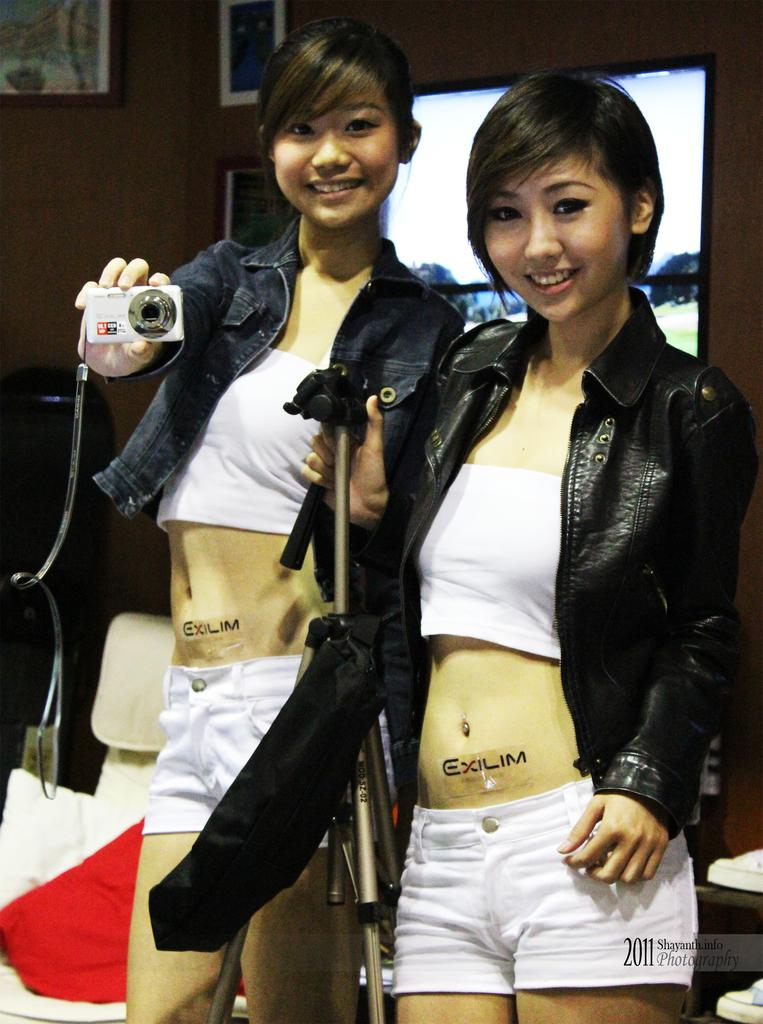How many women are in the image? There are two women in the image. What are the women wearing? Both women are wearing jackets. What expressions do the women have? Both women are smiling. What objects are the women holding? One woman is holding a camera, and the other woman is holding a camera stand. What can be seen on the wall in the background? There are pictures on the wall in the background. What is attached to the wall in the background? There is a screen attached to the wall in the background. Are the women in the image requesting assistance from the dogs? There are no dogs present in the image, so it is not possible to determine if the women are requesting assistance from them. 